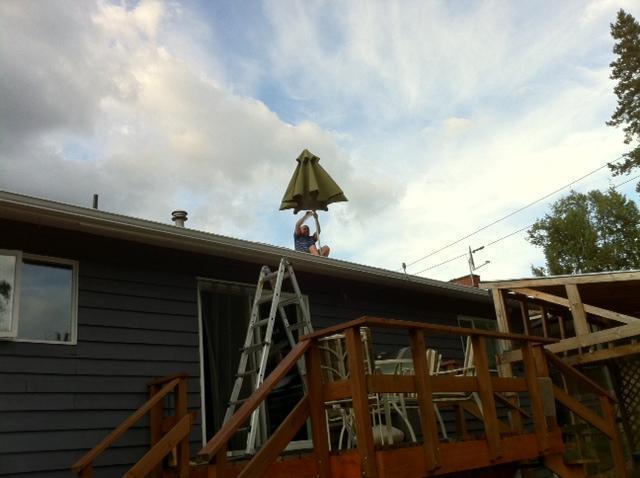What does the item the man is holding provide?
Answer the question by selecting the correct answer among the 4 following choices and explain your choice with a short sentence. The answer should be formatted with the following format: `Answer: choice
Rationale: rationale.`
Options: Fruit, shade, water, milk. Answer: shade.
Rationale: The item the man is holding is an umbrella which provides shade from the sun. 